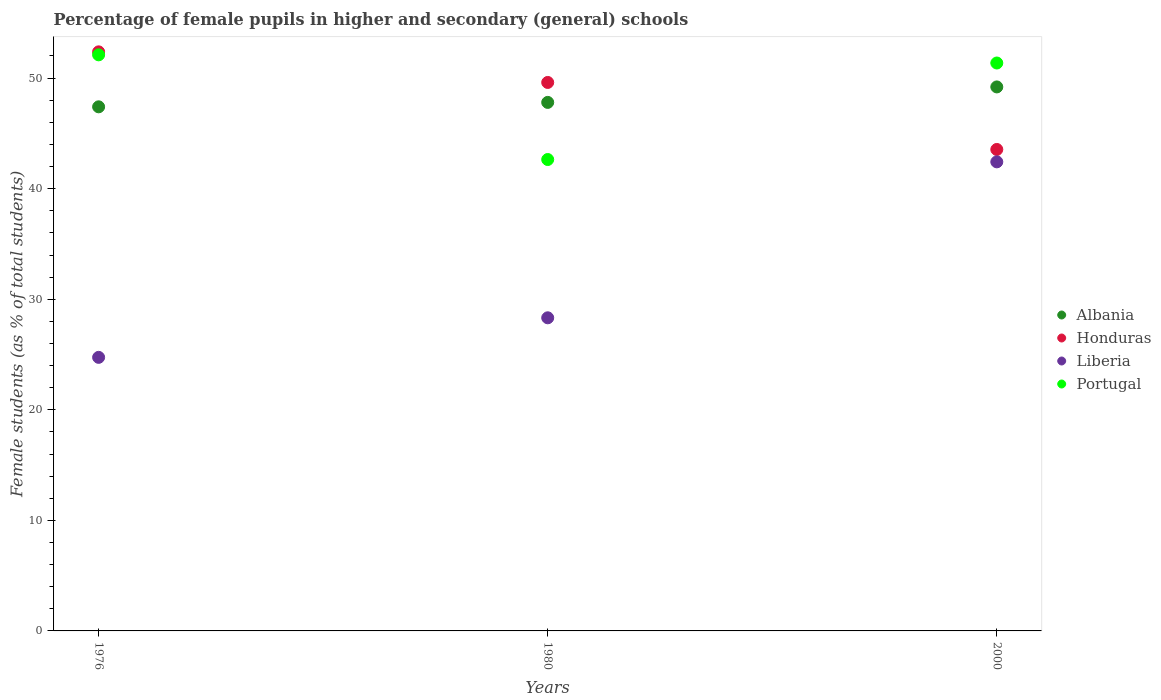How many different coloured dotlines are there?
Give a very brief answer. 4. What is the percentage of female pupils in higher and secondary schools in Honduras in 1980?
Provide a succinct answer. 49.61. Across all years, what is the maximum percentage of female pupils in higher and secondary schools in Albania?
Your response must be concise. 49.2. Across all years, what is the minimum percentage of female pupils in higher and secondary schools in Portugal?
Your answer should be very brief. 42.64. In which year was the percentage of female pupils in higher and secondary schools in Portugal maximum?
Make the answer very short. 1976. In which year was the percentage of female pupils in higher and secondary schools in Portugal minimum?
Your answer should be compact. 1980. What is the total percentage of female pupils in higher and secondary schools in Honduras in the graph?
Give a very brief answer. 145.53. What is the difference between the percentage of female pupils in higher and secondary schools in Liberia in 1976 and that in 1980?
Provide a short and direct response. -3.58. What is the difference between the percentage of female pupils in higher and secondary schools in Honduras in 1976 and the percentage of female pupils in higher and secondary schools in Albania in 1980?
Offer a terse response. 4.57. What is the average percentage of female pupils in higher and secondary schools in Albania per year?
Make the answer very short. 48.14. In the year 1980, what is the difference between the percentage of female pupils in higher and secondary schools in Liberia and percentage of female pupils in higher and secondary schools in Honduras?
Offer a very short reply. -21.29. In how many years, is the percentage of female pupils in higher and secondary schools in Liberia greater than 18 %?
Make the answer very short. 3. What is the ratio of the percentage of female pupils in higher and secondary schools in Albania in 1976 to that in 1980?
Ensure brevity in your answer.  0.99. What is the difference between the highest and the second highest percentage of female pupils in higher and secondary schools in Liberia?
Offer a very short reply. 14.1. What is the difference between the highest and the lowest percentage of female pupils in higher and secondary schools in Albania?
Offer a very short reply. 1.8. Is the sum of the percentage of female pupils in higher and secondary schools in Portugal in 1980 and 2000 greater than the maximum percentage of female pupils in higher and secondary schools in Honduras across all years?
Offer a terse response. Yes. Is the percentage of female pupils in higher and secondary schools in Portugal strictly greater than the percentage of female pupils in higher and secondary schools in Albania over the years?
Your response must be concise. No. Is the percentage of female pupils in higher and secondary schools in Liberia strictly less than the percentage of female pupils in higher and secondary schools in Portugal over the years?
Your answer should be very brief. Yes. What is the difference between two consecutive major ticks on the Y-axis?
Offer a terse response. 10. Does the graph contain grids?
Ensure brevity in your answer.  No. How many legend labels are there?
Your answer should be very brief. 4. How are the legend labels stacked?
Provide a short and direct response. Vertical. What is the title of the graph?
Your response must be concise. Percentage of female pupils in higher and secondary (general) schools. What is the label or title of the Y-axis?
Make the answer very short. Female students (as % of total students). What is the Female students (as % of total students) of Albania in 1976?
Offer a terse response. 47.4. What is the Female students (as % of total students) of Honduras in 1976?
Provide a short and direct response. 52.37. What is the Female students (as % of total students) in Liberia in 1976?
Ensure brevity in your answer.  24.74. What is the Female students (as % of total students) in Portugal in 1976?
Give a very brief answer. 52.1. What is the Female students (as % of total students) of Albania in 1980?
Provide a short and direct response. 47.8. What is the Female students (as % of total students) in Honduras in 1980?
Provide a short and direct response. 49.61. What is the Female students (as % of total students) of Liberia in 1980?
Provide a short and direct response. 28.32. What is the Female students (as % of total students) of Portugal in 1980?
Provide a succinct answer. 42.64. What is the Female students (as % of total students) in Albania in 2000?
Give a very brief answer. 49.2. What is the Female students (as % of total students) in Honduras in 2000?
Give a very brief answer. 43.55. What is the Female students (as % of total students) in Liberia in 2000?
Give a very brief answer. 42.42. What is the Female students (as % of total students) in Portugal in 2000?
Keep it short and to the point. 51.37. Across all years, what is the maximum Female students (as % of total students) in Albania?
Offer a terse response. 49.2. Across all years, what is the maximum Female students (as % of total students) of Honduras?
Provide a short and direct response. 52.37. Across all years, what is the maximum Female students (as % of total students) of Liberia?
Make the answer very short. 42.42. Across all years, what is the maximum Female students (as % of total students) in Portugal?
Give a very brief answer. 52.1. Across all years, what is the minimum Female students (as % of total students) of Albania?
Your answer should be very brief. 47.4. Across all years, what is the minimum Female students (as % of total students) in Honduras?
Make the answer very short. 43.55. Across all years, what is the minimum Female students (as % of total students) of Liberia?
Your response must be concise. 24.74. Across all years, what is the minimum Female students (as % of total students) of Portugal?
Make the answer very short. 42.64. What is the total Female students (as % of total students) of Albania in the graph?
Provide a short and direct response. 144.41. What is the total Female students (as % of total students) in Honduras in the graph?
Your response must be concise. 145.53. What is the total Female students (as % of total students) of Liberia in the graph?
Ensure brevity in your answer.  95.49. What is the total Female students (as % of total students) in Portugal in the graph?
Keep it short and to the point. 146.11. What is the difference between the Female students (as % of total students) of Albania in 1976 and that in 1980?
Offer a very short reply. -0.4. What is the difference between the Female students (as % of total students) in Honduras in 1976 and that in 1980?
Your response must be concise. 2.77. What is the difference between the Female students (as % of total students) of Liberia in 1976 and that in 1980?
Keep it short and to the point. -3.58. What is the difference between the Female students (as % of total students) of Portugal in 1976 and that in 1980?
Make the answer very short. 9.47. What is the difference between the Female students (as % of total students) of Albania in 1976 and that in 2000?
Offer a very short reply. -1.8. What is the difference between the Female students (as % of total students) of Honduras in 1976 and that in 2000?
Give a very brief answer. 8.83. What is the difference between the Female students (as % of total students) of Liberia in 1976 and that in 2000?
Offer a terse response. -17.68. What is the difference between the Female students (as % of total students) in Portugal in 1976 and that in 2000?
Keep it short and to the point. 0.74. What is the difference between the Female students (as % of total students) of Albania in 1980 and that in 2000?
Your response must be concise. -1.4. What is the difference between the Female students (as % of total students) in Honduras in 1980 and that in 2000?
Your answer should be very brief. 6.06. What is the difference between the Female students (as % of total students) in Liberia in 1980 and that in 2000?
Offer a very short reply. -14.1. What is the difference between the Female students (as % of total students) of Portugal in 1980 and that in 2000?
Provide a short and direct response. -8.73. What is the difference between the Female students (as % of total students) in Albania in 1976 and the Female students (as % of total students) in Honduras in 1980?
Provide a short and direct response. -2.2. What is the difference between the Female students (as % of total students) of Albania in 1976 and the Female students (as % of total students) of Liberia in 1980?
Provide a succinct answer. 19.08. What is the difference between the Female students (as % of total students) in Albania in 1976 and the Female students (as % of total students) in Portugal in 1980?
Provide a succinct answer. 4.77. What is the difference between the Female students (as % of total students) in Honduras in 1976 and the Female students (as % of total students) in Liberia in 1980?
Ensure brevity in your answer.  24.05. What is the difference between the Female students (as % of total students) in Honduras in 1976 and the Female students (as % of total students) in Portugal in 1980?
Make the answer very short. 9.74. What is the difference between the Female students (as % of total students) in Liberia in 1976 and the Female students (as % of total students) in Portugal in 1980?
Offer a terse response. -17.89. What is the difference between the Female students (as % of total students) in Albania in 1976 and the Female students (as % of total students) in Honduras in 2000?
Offer a very short reply. 3.86. What is the difference between the Female students (as % of total students) in Albania in 1976 and the Female students (as % of total students) in Liberia in 2000?
Give a very brief answer. 4.98. What is the difference between the Female students (as % of total students) of Albania in 1976 and the Female students (as % of total students) of Portugal in 2000?
Keep it short and to the point. -3.96. What is the difference between the Female students (as % of total students) in Honduras in 1976 and the Female students (as % of total students) in Liberia in 2000?
Ensure brevity in your answer.  9.95. What is the difference between the Female students (as % of total students) of Honduras in 1976 and the Female students (as % of total students) of Portugal in 2000?
Provide a succinct answer. 1.01. What is the difference between the Female students (as % of total students) in Liberia in 1976 and the Female students (as % of total students) in Portugal in 2000?
Make the answer very short. -26.62. What is the difference between the Female students (as % of total students) of Albania in 1980 and the Female students (as % of total students) of Honduras in 2000?
Offer a terse response. 4.26. What is the difference between the Female students (as % of total students) of Albania in 1980 and the Female students (as % of total students) of Liberia in 2000?
Your answer should be compact. 5.38. What is the difference between the Female students (as % of total students) of Albania in 1980 and the Female students (as % of total students) of Portugal in 2000?
Make the answer very short. -3.56. What is the difference between the Female students (as % of total students) of Honduras in 1980 and the Female students (as % of total students) of Liberia in 2000?
Offer a terse response. 7.18. What is the difference between the Female students (as % of total students) of Honduras in 1980 and the Female students (as % of total students) of Portugal in 2000?
Ensure brevity in your answer.  -1.76. What is the difference between the Female students (as % of total students) in Liberia in 1980 and the Female students (as % of total students) in Portugal in 2000?
Provide a succinct answer. -23.04. What is the average Female students (as % of total students) of Albania per year?
Give a very brief answer. 48.14. What is the average Female students (as % of total students) in Honduras per year?
Offer a very short reply. 48.51. What is the average Female students (as % of total students) in Liberia per year?
Provide a short and direct response. 31.83. What is the average Female students (as % of total students) of Portugal per year?
Provide a succinct answer. 48.7. In the year 1976, what is the difference between the Female students (as % of total students) of Albania and Female students (as % of total students) of Honduras?
Make the answer very short. -4.97. In the year 1976, what is the difference between the Female students (as % of total students) of Albania and Female students (as % of total students) of Liberia?
Offer a very short reply. 22.66. In the year 1976, what is the difference between the Female students (as % of total students) in Albania and Female students (as % of total students) in Portugal?
Give a very brief answer. -4.7. In the year 1976, what is the difference between the Female students (as % of total students) of Honduras and Female students (as % of total students) of Liberia?
Your response must be concise. 27.63. In the year 1976, what is the difference between the Female students (as % of total students) in Honduras and Female students (as % of total students) in Portugal?
Ensure brevity in your answer.  0.27. In the year 1976, what is the difference between the Female students (as % of total students) of Liberia and Female students (as % of total students) of Portugal?
Ensure brevity in your answer.  -27.36. In the year 1980, what is the difference between the Female students (as % of total students) of Albania and Female students (as % of total students) of Honduras?
Make the answer very short. -1.8. In the year 1980, what is the difference between the Female students (as % of total students) in Albania and Female students (as % of total students) in Liberia?
Give a very brief answer. 19.48. In the year 1980, what is the difference between the Female students (as % of total students) in Albania and Female students (as % of total students) in Portugal?
Provide a short and direct response. 5.17. In the year 1980, what is the difference between the Female students (as % of total students) of Honduras and Female students (as % of total students) of Liberia?
Provide a succinct answer. 21.29. In the year 1980, what is the difference between the Female students (as % of total students) of Honduras and Female students (as % of total students) of Portugal?
Provide a succinct answer. 6.97. In the year 1980, what is the difference between the Female students (as % of total students) of Liberia and Female students (as % of total students) of Portugal?
Provide a short and direct response. -14.32. In the year 2000, what is the difference between the Female students (as % of total students) in Albania and Female students (as % of total students) in Honduras?
Your answer should be compact. 5.66. In the year 2000, what is the difference between the Female students (as % of total students) of Albania and Female students (as % of total students) of Liberia?
Make the answer very short. 6.78. In the year 2000, what is the difference between the Female students (as % of total students) of Albania and Female students (as % of total students) of Portugal?
Your answer should be compact. -2.16. In the year 2000, what is the difference between the Female students (as % of total students) in Honduras and Female students (as % of total students) in Liberia?
Offer a very short reply. 1.12. In the year 2000, what is the difference between the Female students (as % of total students) in Honduras and Female students (as % of total students) in Portugal?
Provide a short and direct response. -7.82. In the year 2000, what is the difference between the Female students (as % of total students) of Liberia and Female students (as % of total students) of Portugal?
Offer a terse response. -8.94. What is the ratio of the Female students (as % of total students) in Honduras in 1976 to that in 1980?
Your response must be concise. 1.06. What is the ratio of the Female students (as % of total students) in Liberia in 1976 to that in 1980?
Your response must be concise. 0.87. What is the ratio of the Female students (as % of total students) in Portugal in 1976 to that in 1980?
Ensure brevity in your answer.  1.22. What is the ratio of the Female students (as % of total students) in Albania in 1976 to that in 2000?
Your response must be concise. 0.96. What is the ratio of the Female students (as % of total students) in Honduras in 1976 to that in 2000?
Your answer should be compact. 1.2. What is the ratio of the Female students (as % of total students) in Liberia in 1976 to that in 2000?
Give a very brief answer. 0.58. What is the ratio of the Female students (as % of total students) in Portugal in 1976 to that in 2000?
Provide a succinct answer. 1.01. What is the ratio of the Female students (as % of total students) of Albania in 1980 to that in 2000?
Provide a short and direct response. 0.97. What is the ratio of the Female students (as % of total students) in Honduras in 1980 to that in 2000?
Offer a very short reply. 1.14. What is the ratio of the Female students (as % of total students) of Liberia in 1980 to that in 2000?
Your answer should be very brief. 0.67. What is the ratio of the Female students (as % of total students) in Portugal in 1980 to that in 2000?
Your answer should be compact. 0.83. What is the difference between the highest and the second highest Female students (as % of total students) of Albania?
Provide a short and direct response. 1.4. What is the difference between the highest and the second highest Female students (as % of total students) of Honduras?
Keep it short and to the point. 2.77. What is the difference between the highest and the second highest Female students (as % of total students) of Liberia?
Make the answer very short. 14.1. What is the difference between the highest and the second highest Female students (as % of total students) in Portugal?
Offer a terse response. 0.74. What is the difference between the highest and the lowest Female students (as % of total students) in Albania?
Provide a short and direct response. 1.8. What is the difference between the highest and the lowest Female students (as % of total students) of Honduras?
Your answer should be very brief. 8.83. What is the difference between the highest and the lowest Female students (as % of total students) in Liberia?
Offer a very short reply. 17.68. What is the difference between the highest and the lowest Female students (as % of total students) of Portugal?
Offer a terse response. 9.47. 